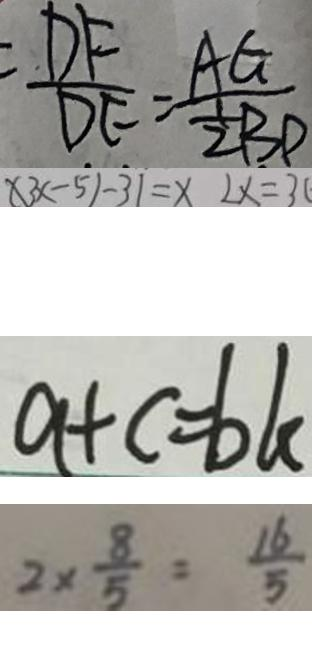Convert formula to latex. <formula><loc_0><loc_0><loc_500><loc_500>\frac { D F } { D E } = \frac { A G } { \frac { 1 } { 2 } B D } 
 \times 3 x - 5 ) - 3 1 = x 2 x = 3 ( 
 a + c = b k 
 2 \times \frac { 8 } { 5 } = \frac { 1 6 } { 5 }</formula> 